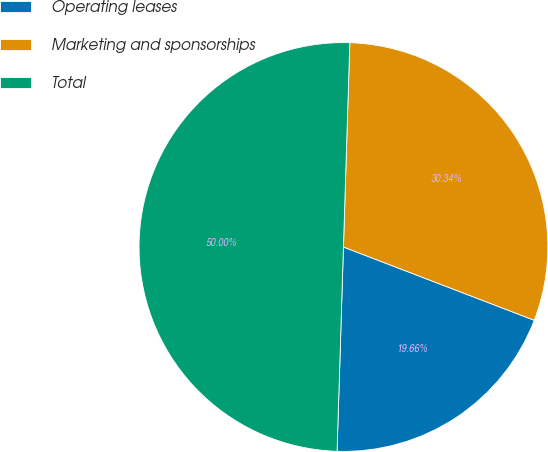Convert chart. <chart><loc_0><loc_0><loc_500><loc_500><pie_chart><fcel>Operating leases<fcel>Marketing and sponsorships<fcel>Total<nl><fcel>19.66%<fcel>30.34%<fcel>50.0%<nl></chart> 